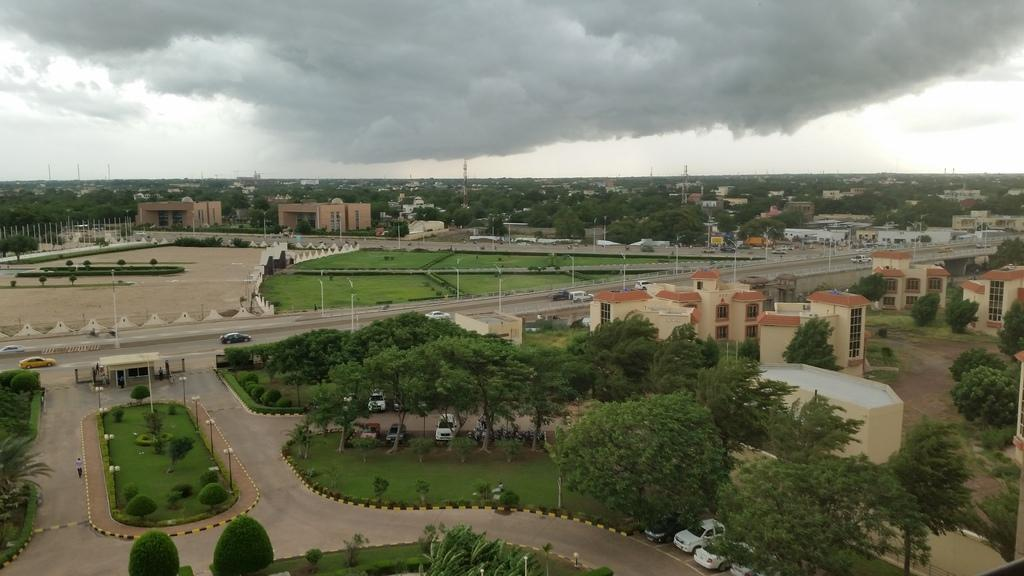What type of vegetation is present in the image? There are trees in the image. What is located under the trees? There are vehicles parked under the trees. What structures can be seen on the right side of the image? There are buildings on the right side of the image. What is visible at the top of the image? The sky is visible at the top of the image. How would you describe the sky in the image? The sky appears to be cloudy. How many visitors are sitting on the cloud in the image? There are no visitors or clouds present in the image. What type of street can be seen in the image? There is no street visible in the image; it features trees, vehicles, buildings, and a cloudy sky. 